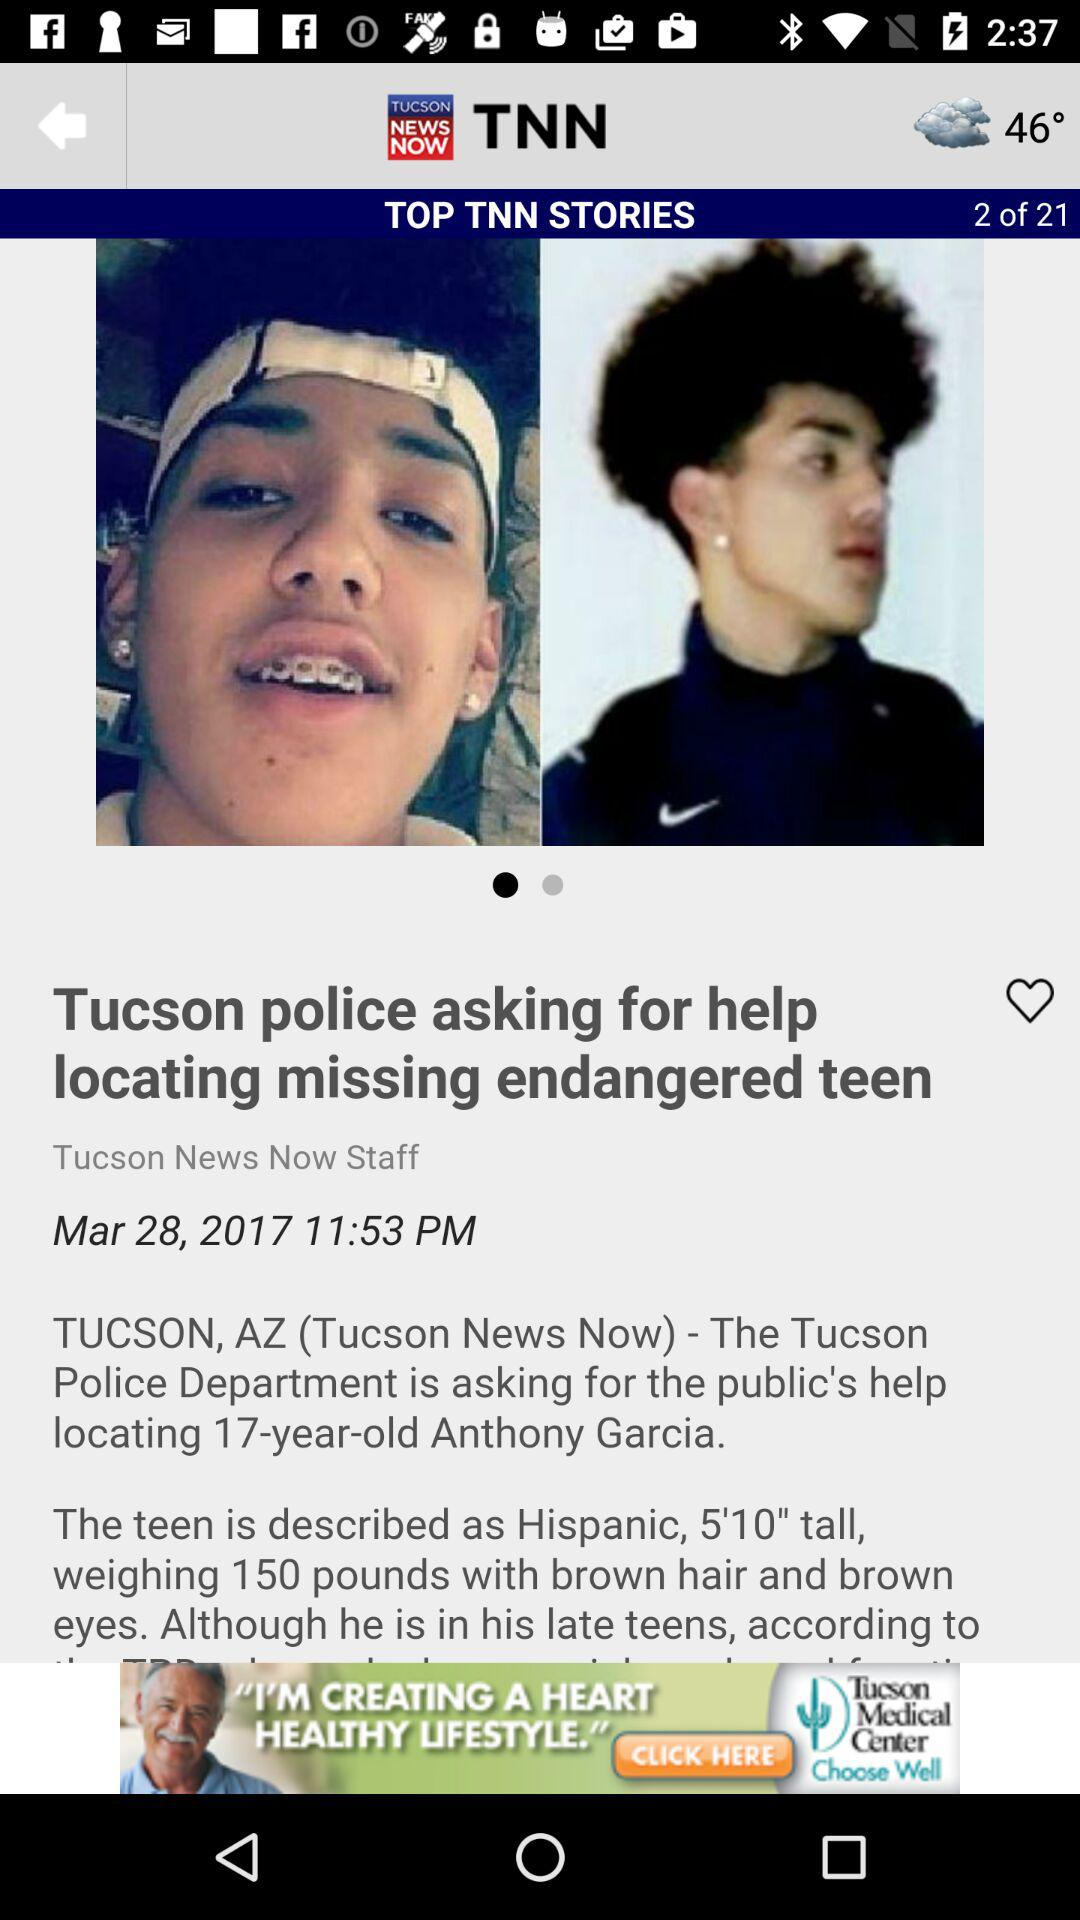How much does Anthony weigh? Anthony weighs 150 pounds. 